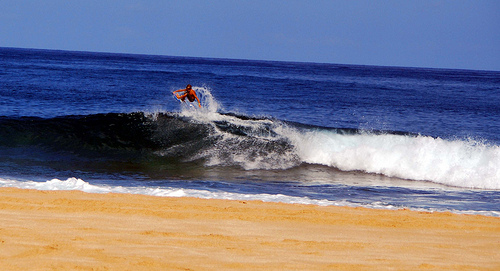Please provide the bounding box coordinate of the region this sentence describes: a man riding the wave. To vividly grasp the surfer's admirable balance and skill as he rides the wave, the bounding box should ideally be [0.20, 0.29, 0.77, 0.69], highlighting his centered stance atop the surfboard's length. 